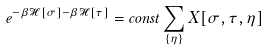Convert formula to latex. <formula><loc_0><loc_0><loc_500><loc_500>e ^ { - \beta \mathcal { H } [ \sigma ] - \beta \mathcal { H } [ \tau ] } = c o n s t \sum _ { \{ \eta \} } X [ \sigma , \tau , \eta ]</formula> 